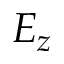Convert formula to latex. <formula><loc_0><loc_0><loc_500><loc_500>E _ { z }</formula> 